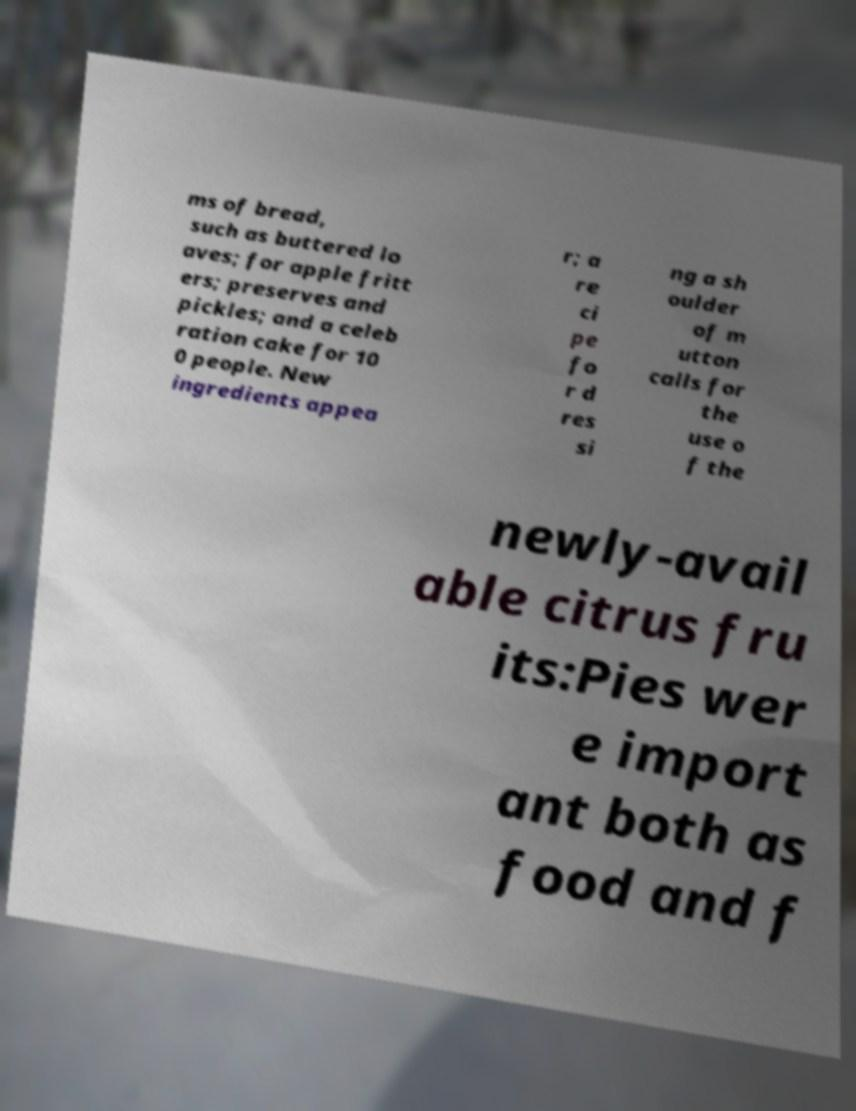I need the written content from this picture converted into text. Can you do that? ms of bread, such as buttered lo aves; for apple fritt ers; preserves and pickles; and a celeb ration cake for 10 0 people. New ingredients appea r; a re ci pe fo r d res si ng a sh oulder of m utton calls for the use o f the newly-avail able citrus fru its:Pies wer e import ant both as food and f 